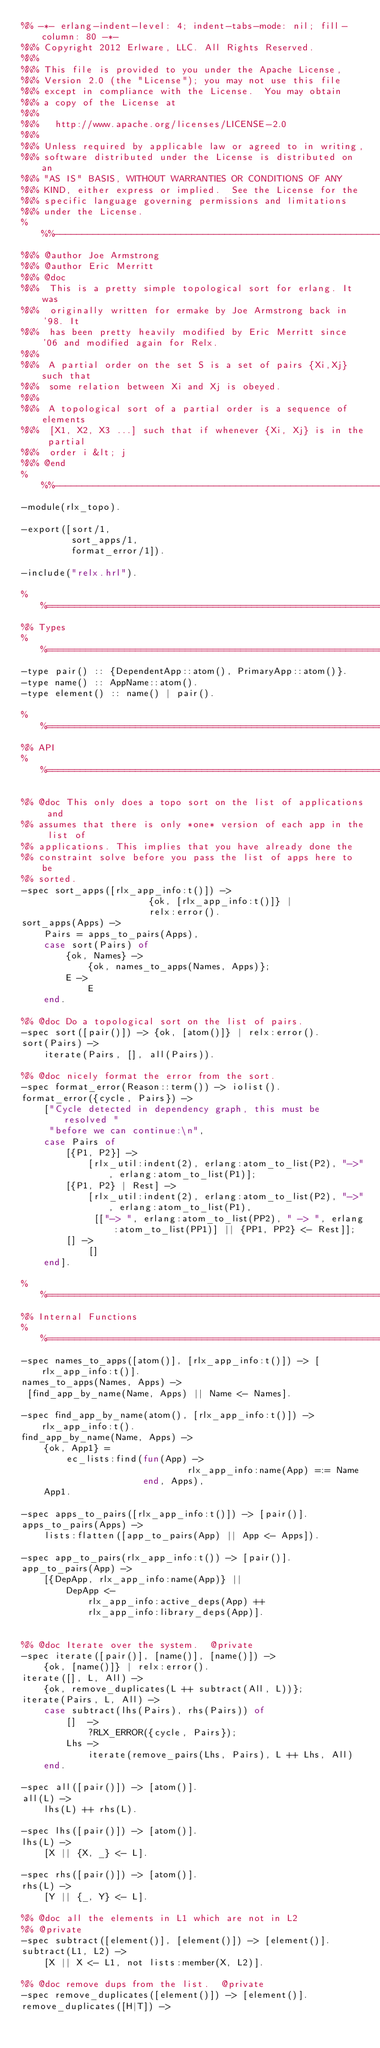Convert code to text. <code><loc_0><loc_0><loc_500><loc_500><_Erlang_>%% -*- erlang-indent-level: 4; indent-tabs-mode: nil; fill-column: 80 -*-
%%% Copyright 2012 Erlware, LLC. All Rights Reserved.
%%%
%%% This file is provided to you under the Apache License,
%%% Version 2.0 (the "License"); you may not use this file
%%% except in compliance with the License.  You may obtain
%%% a copy of the License at
%%%
%%%   http://www.apache.org/licenses/LICENSE-2.0
%%%
%%% Unless required by applicable law or agreed to in writing,
%%% software distributed under the License is distributed on an
%%% "AS IS" BASIS, WITHOUT WARRANTIES OR CONDITIONS OF ANY
%%% KIND, either express or implied.  See the License for the
%%% specific language governing permissions and limitations
%%% under the License.
%%%-------------------------------------------------------------------
%%% @author Joe Armstrong
%%% @author Eric Merritt
%%% @doc
%%%  This is a pretty simple topological sort for erlang. It was
%%%  originally written for ermake by Joe Armstrong back in '98. It
%%%  has been pretty heavily modified by Eric Merritt since '06 and modified again for Relx.
%%%
%%%  A partial order on the set S is a set of pairs {Xi,Xj} such that
%%%  some relation between Xi and Xj is obeyed.
%%%
%%%  A topological sort of a partial order is a sequence of elements
%%%  [X1, X2, X3 ...] such that if whenever {Xi, Xj} is in the partial
%%%  order i &lt; j
%%% @end
%%%-------------------------------------------------------------------
-module(rlx_topo).

-export([sort/1,
         sort_apps/1,
         format_error/1]).

-include("relx.hrl").

%%====================================================================
%% Types
%%====================================================================
-type pair() :: {DependentApp::atom(), PrimaryApp::atom()}.
-type name() :: AppName::atom().
-type element() :: name() | pair().

%%====================================================================
%% API
%%====================================================================

%% @doc This only does a topo sort on the list of applications and
%% assumes that there is only *one* version of each app in the list of
%% applications. This implies that you have already done the
%% constraint solve before you pass the list of apps here to be
%% sorted.
-spec sort_apps([rlx_app_info:t()]) ->
                       {ok, [rlx_app_info:t()]} |
                       relx:error().
sort_apps(Apps) ->
    Pairs = apps_to_pairs(Apps),
    case sort(Pairs) of
        {ok, Names} ->
            {ok, names_to_apps(Names, Apps)};
        E ->
            E
    end.

%% @doc Do a topological sort on the list of pairs.
-spec sort([pair()]) -> {ok, [atom()]} | relx:error().
sort(Pairs) ->
    iterate(Pairs, [], all(Pairs)).

%% @doc nicely format the error from the sort.
-spec format_error(Reason::term()) -> iolist().
format_error({cycle, Pairs}) ->
    ["Cycle detected in dependency graph, this must be resolved "
     "before we can continue:\n",
    case Pairs of
        [{P1, P2}] ->
            [rlx_util:indent(2), erlang:atom_to_list(P2), "->", erlang:atom_to_list(P1)];
        [{P1, P2} | Rest] ->
            [rlx_util:indent(2), erlang:atom_to_list(P2), "->", erlang:atom_to_list(P1),
             [["-> ", erlang:atom_to_list(PP2), " -> ", erlang:atom_to_list(PP1)] || {PP1, PP2} <- Rest]];
        [] ->
            []
    end].

%%====================================================================
%% Internal Functions
%%====================================================================
-spec names_to_apps([atom()], [rlx_app_info:t()]) -> [rlx_app_info:t()].
names_to_apps(Names, Apps) ->
 [find_app_by_name(Name, Apps) || Name <- Names].

-spec find_app_by_name(atom(), [rlx_app_info:t()]) -> rlx_app_info:t().
find_app_by_name(Name, Apps) ->
    {ok, App1} =
        ec_lists:find(fun(App) ->
                              rlx_app_info:name(App) =:= Name
                      end, Apps),
    App1.

-spec apps_to_pairs([rlx_app_info:t()]) -> [pair()].
apps_to_pairs(Apps) ->
    lists:flatten([app_to_pairs(App) || App <- Apps]).

-spec app_to_pairs(rlx_app_info:t()) -> [pair()].
app_to_pairs(App) ->
    [{DepApp, rlx_app_info:name(App)} ||
        DepApp <-
            rlx_app_info:active_deps(App) ++
            rlx_app_info:library_deps(App)].


%% @doc Iterate over the system.  @private
-spec iterate([pair()], [name()], [name()]) ->
    {ok, [name()]} | relx:error().
iterate([], L, All) ->
    {ok, remove_duplicates(L ++ subtract(All, L))};
iterate(Pairs, L, All) ->
    case subtract(lhs(Pairs), rhs(Pairs)) of
        []  ->
            ?RLX_ERROR({cycle, Pairs});
        Lhs ->
            iterate(remove_pairs(Lhs, Pairs), L ++ Lhs, All)
    end.

-spec all([pair()]) -> [atom()].
all(L) ->
    lhs(L) ++ rhs(L).

-spec lhs([pair()]) -> [atom()].
lhs(L) ->
    [X || {X, _} <- L].

-spec rhs([pair()]) -> [atom()].
rhs(L) ->
    [Y || {_, Y} <- L].

%% @doc all the elements in L1 which are not in L2
%% @private
-spec subtract([element()], [element()]) -> [element()].
subtract(L1, L2) ->
    [X || X <- L1, not lists:member(X, L2)].

%% @doc remove dups from the list.  @private
-spec remove_duplicates([element()]) -> [element()].
remove_duplicates([H|T]) -></code> 